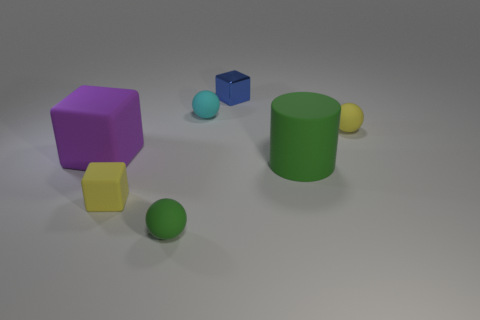What size is the green cylinder that is the same material as the small cyan thing?
Offer a very short reply. Large. What number of large things have the same color as the metal block?
Make the answer very short. 0. Is the number of cyan matte things that are on the left side of the small yellow matte cube less than the number of large matte cubes that are right of the big cube?
Your response must be concise. No. Does the big matte thing that is left of the green sphere have the same shape as the blue metal thing?
Your answer should be compact. Yes. Is there any other thing that has the same material as the purple cube?
Offer a terse response. Yes. Are the object to the left of the yellow rubber block and the cyan object made of the same material?
Your response must be concise. Yes. There is a sphere on the right side of the large object that is right of the tiny green rubber object in front of the tiny yellow ball; what is it made of?
Offer a terse response. Rubber. What number of other objects are there of the same shape as the tiny green thing?
Your answer should be very brief. 2. There is a small matte sphere that is behind the tiny yellow matte ball; what color is it?
Offer a terse response. Cyan. There is a green matte thing that is behind the small ball in front of the large green cylinder; how many tiny cyan rubber balls are to the left of it?
Offer a terse response. 1. 